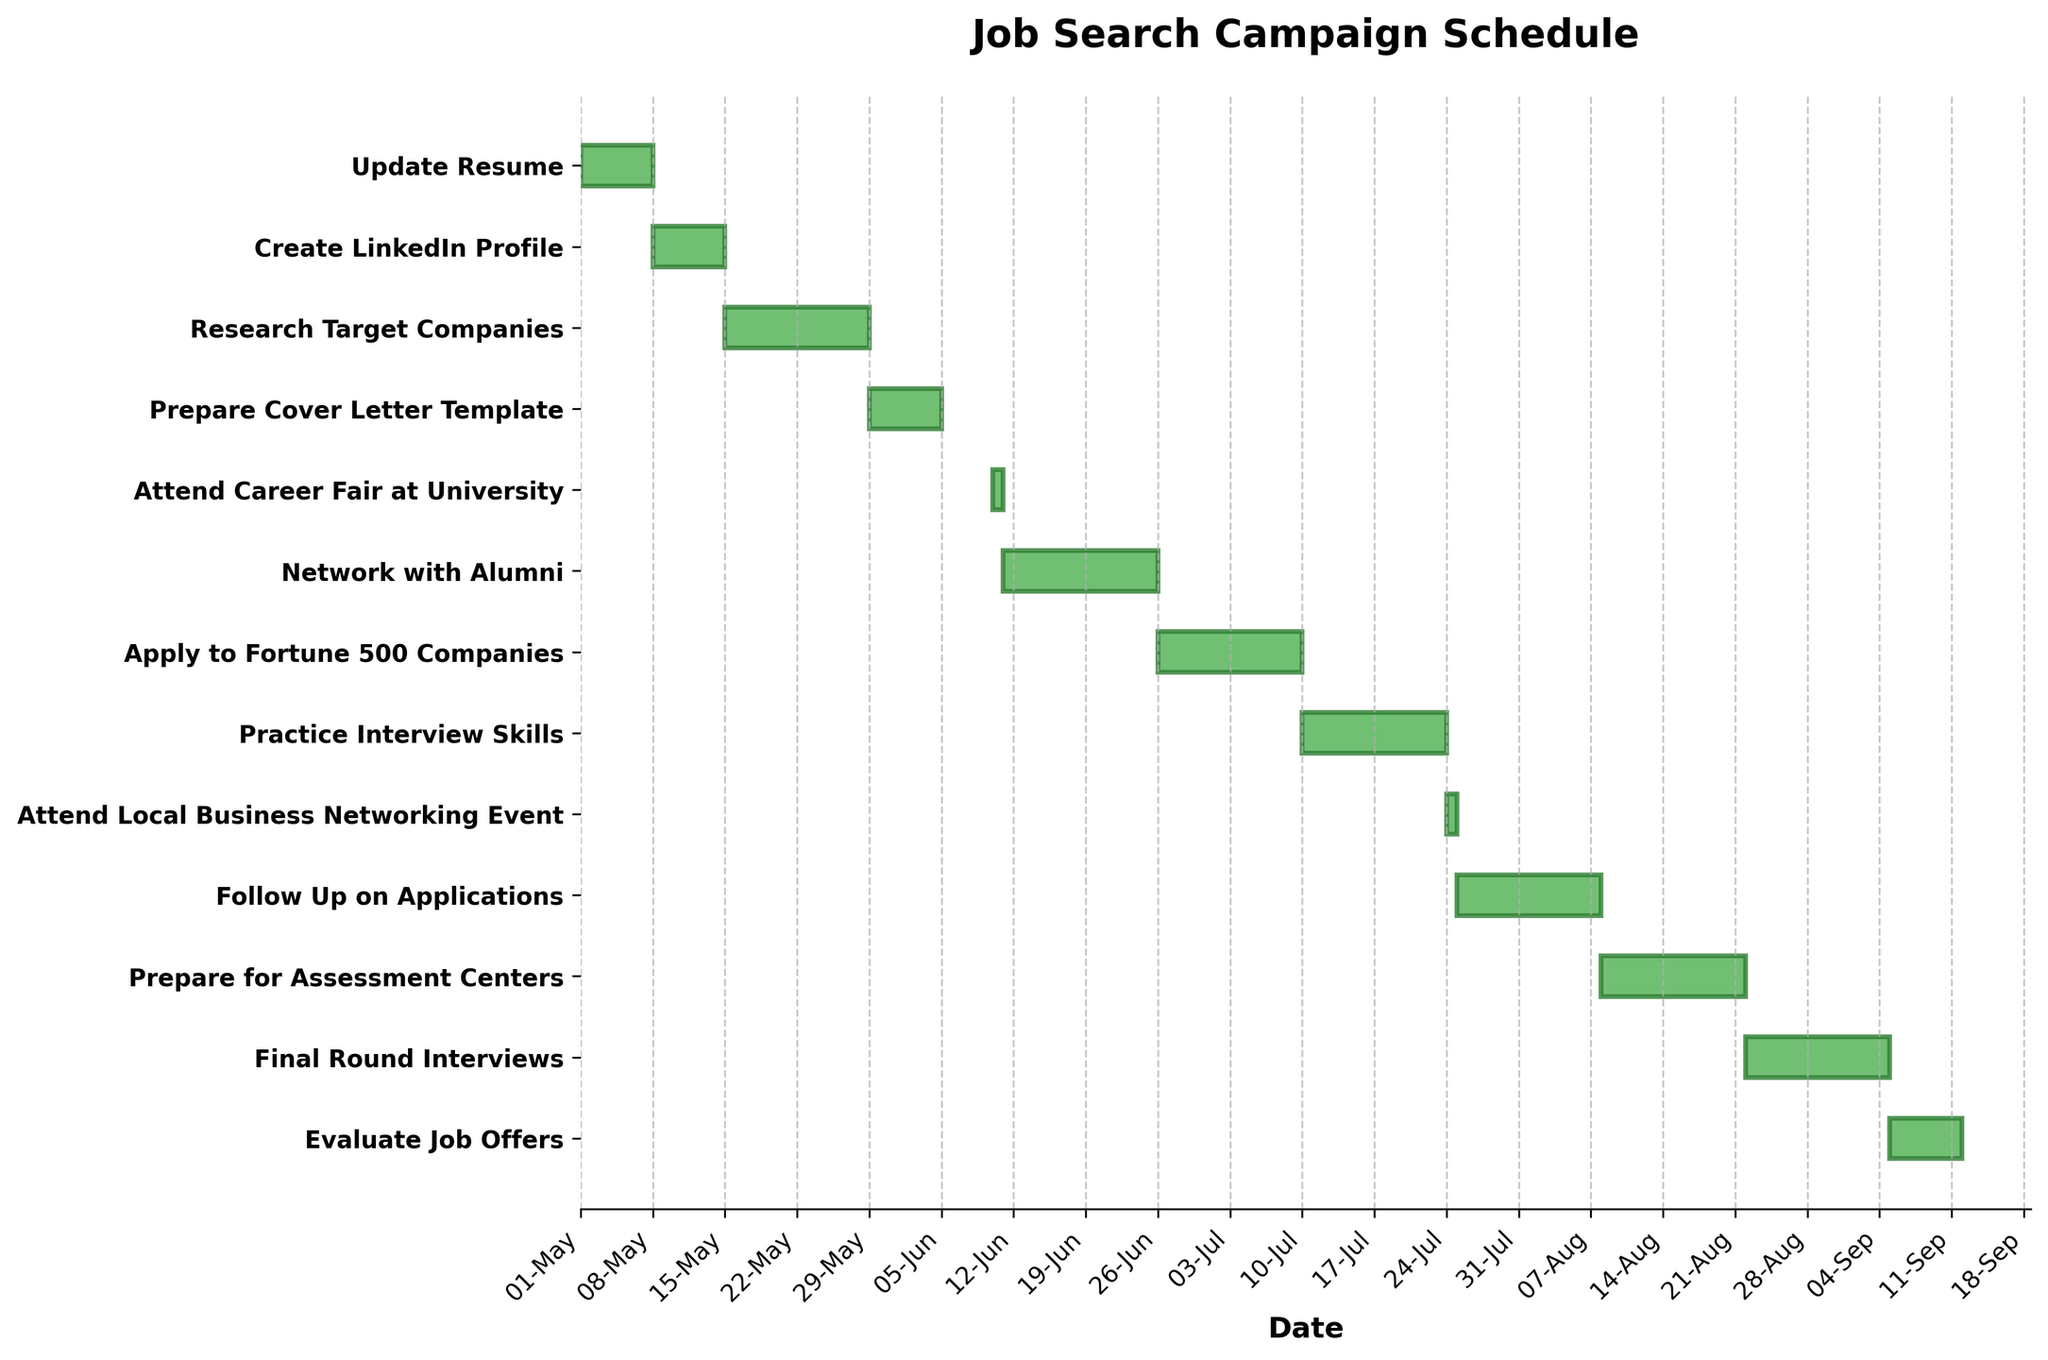When does the job search campaign schedule start and end? The schedule starts with the "Update Resume" task on 2023-05-01 and ends with the "Evaluate Job Offers" task on 2023-09-11.
Answer: 2023-05-01 to 2023-09-11 How many tasks are there in the job search campaign? Count the number of tasks listed on the y-axis. There are 13 tasks in total.
Answer: 13 Which task has the shortest duration? Find the task with the shortest bar. "Attend Career Fair at University" and "Attend Local Business Networking Event" both have durations of only one day.
Answer: Attend Career Fair at University and Attend Local Business Networking Event Which task lasts the longest? Look for the task with the longest horizontal bar. "Network with Alumni" has the longest duration, spanning from 2023-06-11 to 2023-06-25.
Answer: Network with Alumni How many tasks are scheduled to start in May 2023? Determine which tasks start in May by looking at the start dates for each task. There are 4 tasks: "Update Resume," "Create LinkedIn Profile," "Research Target Companies," and "Prepare Cover Letter Template."
Answer: 4 What tasks overlap with the "Network with Alumni" task? Identify tasks that have start or end dates falling within 2023-06-11 to 2023-06-25. Only "Attend Career Fair at University" overlaps with this task on 2023-06-10.
Answer: Attend Career Fair at University Which tasks are scheduled to be completed before June 2023? Look at each task's end date and find those that finish before June. The tasks are "Update Resume," "Create LinkedIn Profile," "Research Target Companies," and "Prepare Cover Letter Template."
Answer: Update Resume, Create LinkedIn Profile, Research Target Companies, Prepare Cover Letter Template How many days are allocated to "Apply to Fortune 500 Companies"? Calculate the duration by subtracting the start date from the end date and adding one. The task runs from 2023-06-26 to 2023-07-09, so the duration is (2023-07-09 - 2023-06-26).days + 1 = 14 days.
Answer: 14 days What is the average duration of all tasks in the schedule? Add up the total days across all tasks and divide by the number of tasks. (7 + 7 + 14 + 7 + 1 + 15 + 14 + 14 + 1 + 14 + 14 + 14 + 7) / 13 = 10.154 (rounded to three decimal places).
Answer: 10.154 days 